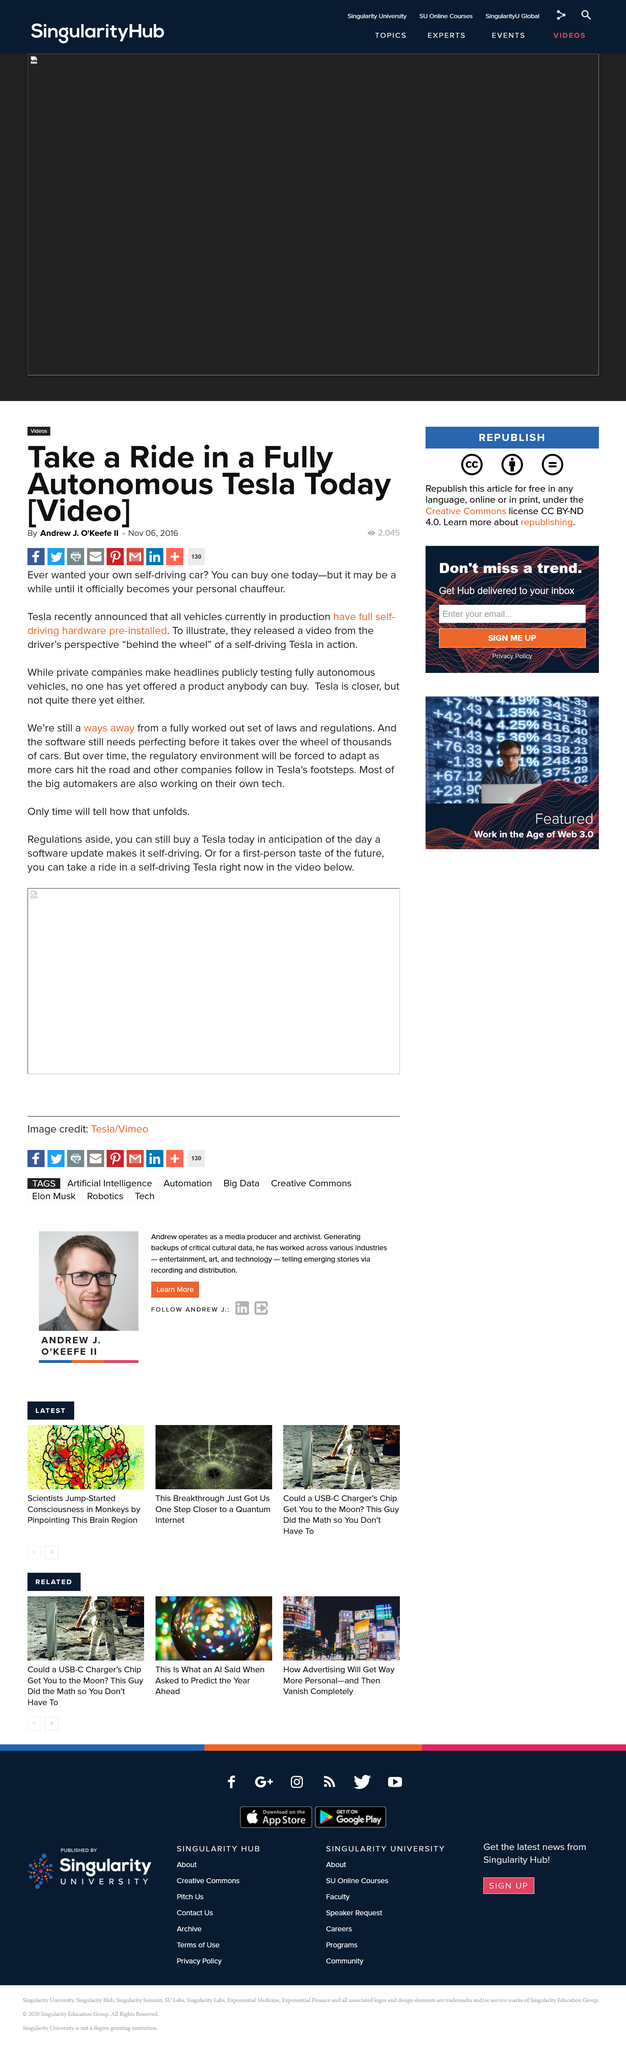Highlight a few significant elements in this photo. As of my knowledge cutoff date of September 2021, no company has yet launched a product with fully functional self-driving technology that is available for public purchase. The development of self-driving technology by various car companies, including Tesla, has been widely acknowledged, with most major automakers actively working on their own autonomous vehicle initiatives. Every Tesla vehicle has pre-installed full self-driving hardware, which enables them to operate with advanced autonomous capabilities. 